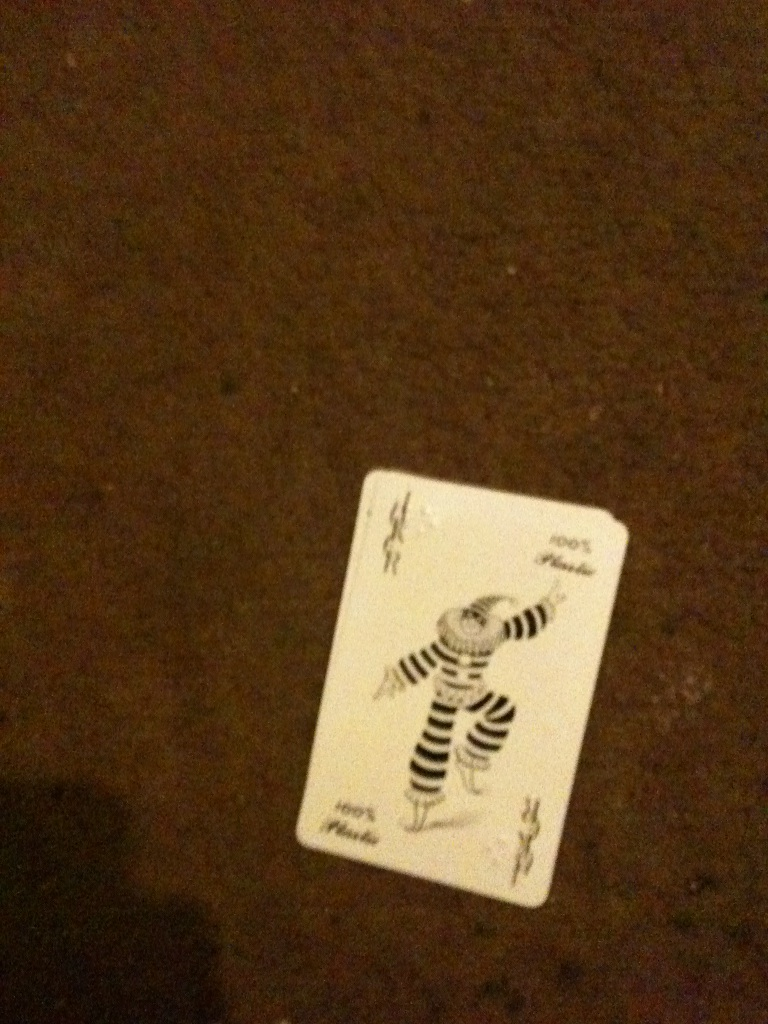Create a short story involving the character on the card. Once upon a time in a magical kingdom, there was a mischievous jester named Jolly who loved to entertain the royal court with his antics. One day, the kingdom fell under a dark curse, and all the colors began to fade away. Jolly, with his cheerfulness and magical powers, set off on a grand adventure to restore the vibrancy of the world. Along his journey, he met various fantastical creatures, each contributing a bit of their own magic to aid him. Ultimately, with courage and laughter, Jolly managed to break the curse, bringing back the hues of life and ensuring that the kingdom would always be filled with laughter and joy. 